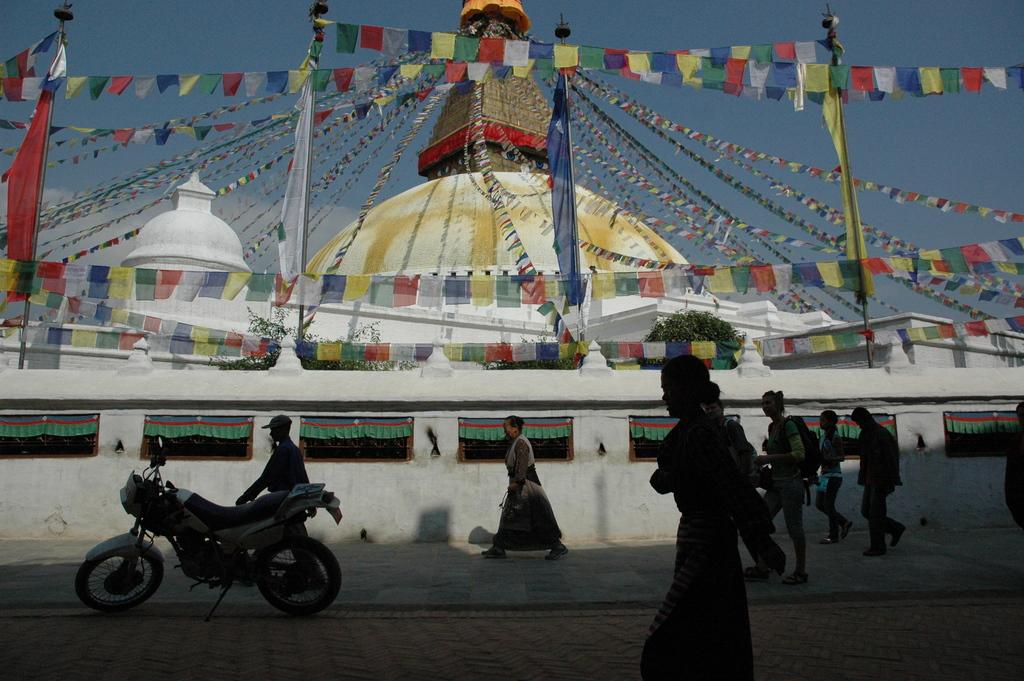Who can be seen in the image? There are men and women in the image. What are the people in the image doing? They are walking on a street. What can be seen in the background of the image? There is a white color Buddha temple in the background. What additional features are present on the temple? The temple has decorative colorful flags. What type of oatmeal is being served at the temple in the image? There is no oatmeal present in the image, as it features men and women walking on a street with a white color Buddha temple in the background. How many brains can be seen in the image? There are no brains visible in the image; it features men and women walking on a street with a white color Buddha temple in the background. 